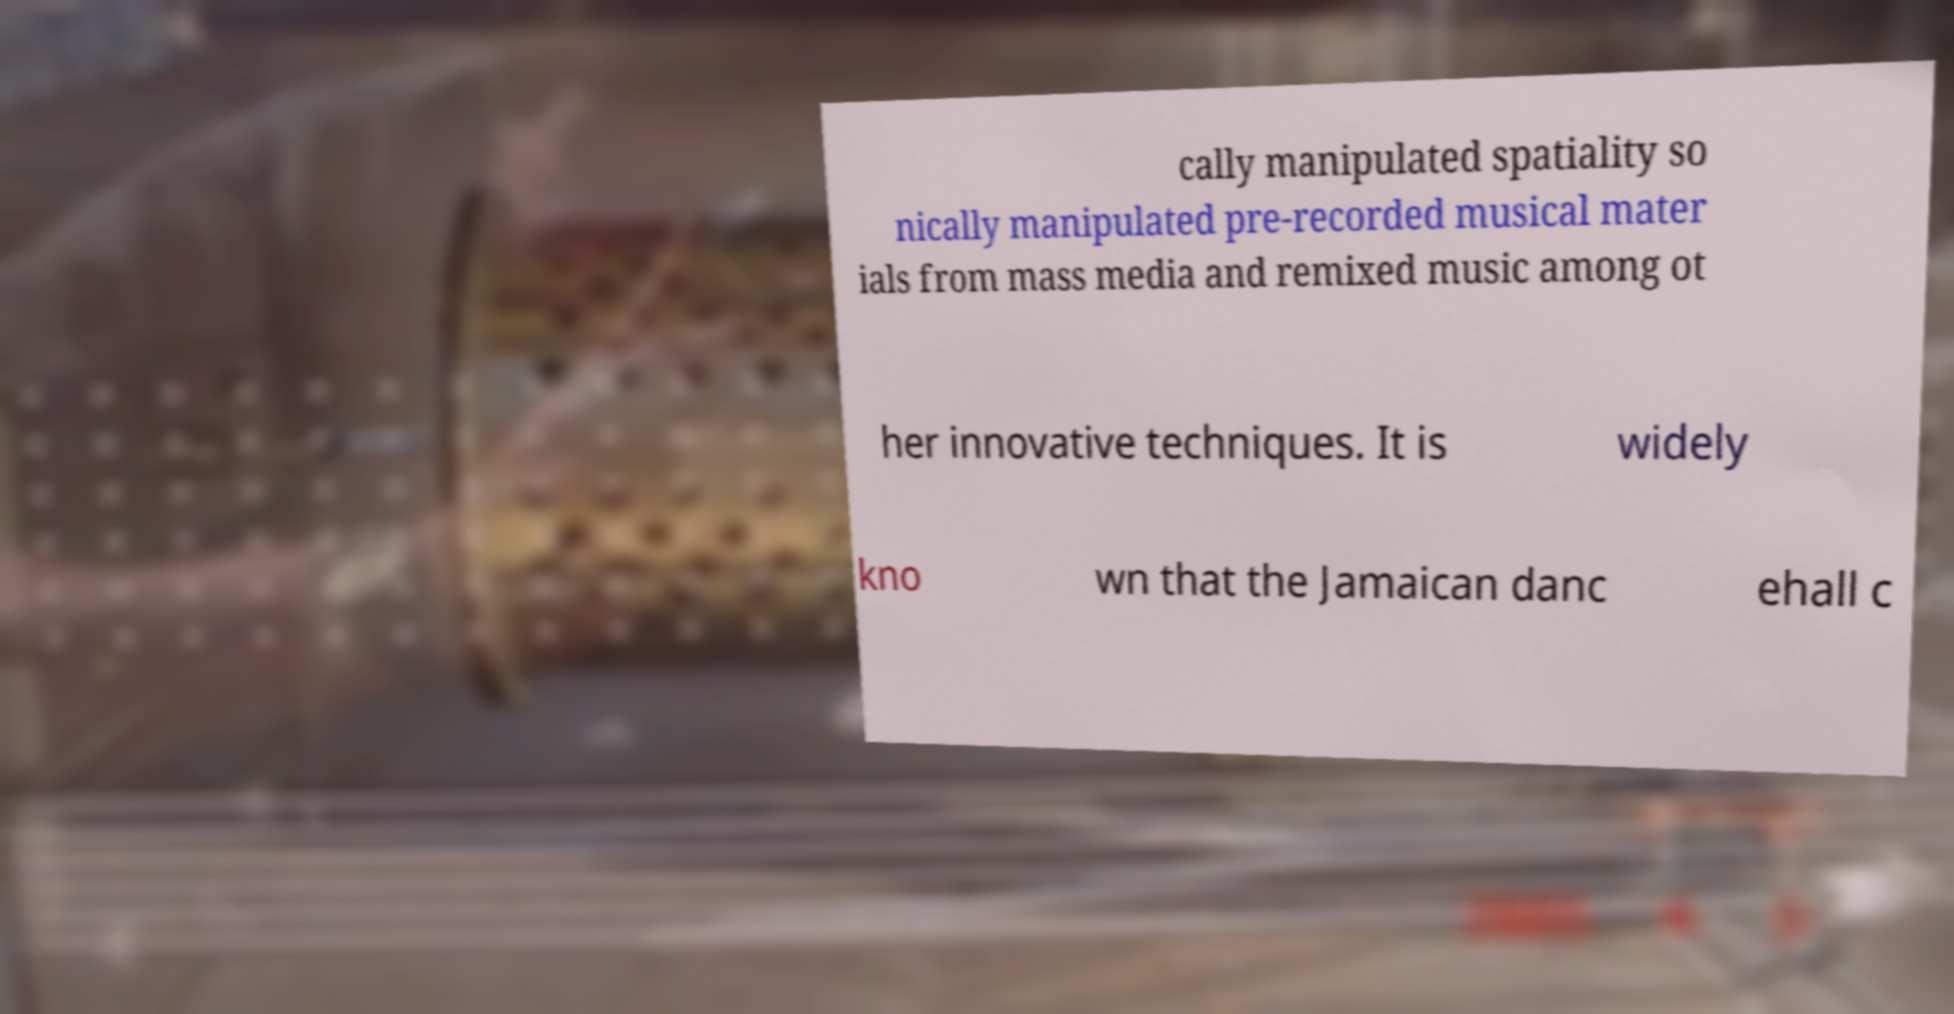What messages or text are displayed in this image? I need them in a readable, typed format. cally manipulated spatiality so nically manipulated pre-recorded musical mater ials from mass media and remixed music among ot her innovative techniques. It is widely kno wn that the Jamaican danc ehall c 